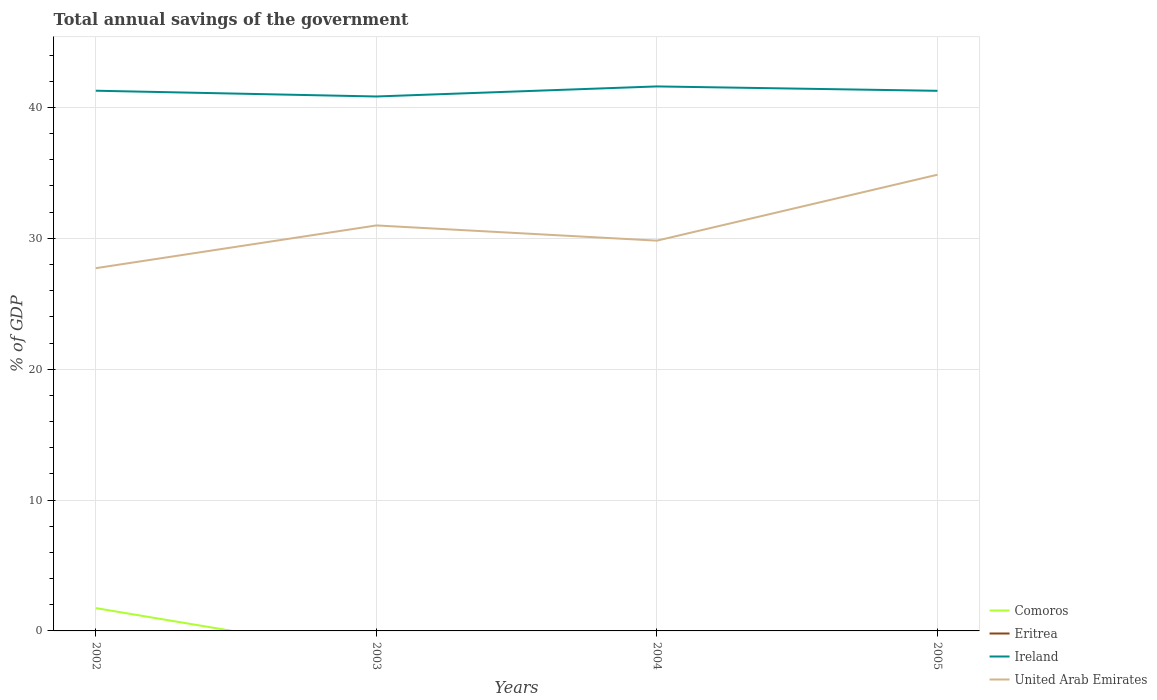What is the total total annual savings of the government in Ireland in the graph?
Make the answer very short. 0.34. What is the difference between the highest and the second highest total annual savings of the government in United Arab Emirates?
Make the answer very short. 7.14. How many years are there in the graph?
Your answer should be compact. 4. What is the difference between two consecutive major ticks on the Y-axis?
Give a very brief answer. 10. Are the values on the major ticks of Y-axis written in scientific E-notation?
Offer a terse response. No. Does the graph contain grids?
Ensure brevity in your answer.  Yes. What is the title of the graph?
Give a very brief answer. Total annual savings of the government. What is the label or title of the X-axis?
Your answer should be very brief. Years. What is the label or title of the Y-axis?
Provide a succinct answer. % of GDP. What is the % of GDP of Comoros in 2002?
Your response must be concise. 1.74. What is the % of GDP in Ireland in 2002?
Keep it short and to the point. 41.28. What is the % of GDP of United Arab Emirates in 2002?
Provide a succinct answer. 27.72. What is the % of GDP in Eritrea in 2003?
Keep it short and to the point. 0. What is the % of GDP of Ireland in 2003?
Make the answer very short. 40.84. What is the % of GDP of United Arab Emirates in 2003?
Ensure brevity in your answer.  30.98. What is the % of GDP in Ireland in 2004?
Ensure brevity in your answer.  41.61. What is the % of GDP of United Arab Emirates in 2004?
Offer a very short reply. 29.82. What is the % of GDP in Ireland in 2005?
Your response must be concise. 41.27. What is the % of GDP of United Arab Emirates in 2005?
Ensure brevity in your answer.  34.86. Across all years, what is the maximum % of GDP of Comoros?
Make the answer very short. 1.74. Across all years, what is the maximum % of GDP of Ireland?
Give a very brief answer. 41.61. Across all years, what is the maximum % of GDP of United Arab Emirates?
Provide a short and direct response. 34.86. Across all years, what is the minimum % of GDP of Comoros?
Your response must be concise. 0. Across all years, what is the minimum % of GDP of Ireland?
Provide a short and direct response. 40.84. Across all years, what is the minimum % of GDP in United Arab Emirates?
Your answer should be very brief. 27.72. What is the total % of GDP in Comoros in the graph?
Your answer should be compact. 1.74. What is the total % of GDP of Ireland in the graph?
Your answer should be compact. 164.99. What is the total % of GDP of United Arab Emirates in the graph?
Give a very brief answer. 123.38. What is the difference between the % of GDP in Ireland in 2002 and that in 2003?
Make the answer very short. 0.44. What is the difference between the % of GDP of United Arab Emirates in 2002 and that in 2003?
Provide a succinct answer. -3.27. What is the difference between the % of GDP in Ireland in 2002 and that in 2004?
Provide a succinct answer. -0.33. What is the difference between the % of GDP in United Arab Emirates in 2002 and that in 2004?
Offer a very short reply. -2.1. What is the difference between the % of GDP in Ireland in 2002 and that in 2005?
Offer a very short reply. 0.01. What is the difference between the % of GDP in United Arab Emirates in 2002 and that in 2005?
Provide a succinct answer. -7.14. What is the difference between the % of GDP in Ireland in 2003 and that in 2004?
Provide a succinct answer. -0.77. What is the difference between the % of GDP in United Arab Emirates in 2003 and that in 2004?
Your answer should be compact. 1.16. What is the difference between the % of GDP in Ireland in 2003 and that in 2005?
Keep it short and to the point. -0.43. What is the difference between the % of GDP of United Arab Emirates in 2003 and that in 2005?
Your response must be concise. -3.88. What is the difference between the % of GDP in Ireland in 2004 and that in 2005?
Make the answer very short. 0.34. What is the difference between the % of GDP of United Arab Emirates in 2004 and that in 2005?
Your answer should be very brief. -5.04. What is the difference between the % of GDP in Comoros in 2002 and the % of GDP in Ireland in 2003?
Your answer should be compact. -39.09. What is the difference between the % of GDP in Comoros in 2002 and the % of GDP in United Arab Emirates in 2003?
Make the answer very short. -29.24. What is the difference between the % of GDP of Ireland in 2002 and the % of GDP of United Arab Emirates in 2003?
Offer a terse response. 10.29. What is the difference between the % of GDP of Comoros in 2002 and the % of GDP of Ireland in 2004?
Ensure brevity in your answer.  -39.86. What is the difference between the % of GDP of Comoros in 2002 and the % of GDP of United Arab Emirates in 2004?
Keep it short and to the point. -28.08. What is the difference between the % of GDP in Ireland in 2002 and the % of GDP in United Arab Emirates in 2004?
Your answer should be compact. 11.46. What is the difference between the % of GDP of Comoros in 2002 and the % of GDP of Ireland in 2005?
Ensure brevity in your answer.  -39.53. What is the difference between the % of GDP in Comoros in 2002 and the % of GDP in United Arab Emirates in 2005?
Provide a succinct answer. -33.12. What is the difference between the % of GDP of Ireland in 2002 and the % of GDP of United Arab Emirates in 2005?
Provide a short and direct response. 6.42. What is the difference between the % of GDP in Ireland in 2003 and the % of GDP in United Arab Emirates in 2004?
Provide a succinct answer. 11.02. What is the difference between the % of GDP of Ireland in 2003 and the % of GDP of United Arab Emirates in 2005?
Your answer should be compact. 5.98. What is the difference between the % of GDP in Ireland in 2004 and the % of GDP in United Arab Emirates in 2005?
Provide a short and direct response. 6.75. What is the average % of GDP of Comoros per year?
Give a very brief answer. 0.44. What is the average % of GDP in Ireland per year?
Provide a succinct answer. 41.25. What is the average % of GDP in United Arab Emirates per year?
Your answer should be compact. 30.85. In the year 2002, what is the difference between the % of GDP of Comoros and % of GDP of Ireland?
Give a very brief answer. -39.53. In the year 2002, what is the difference between the % of GDP of Comoros and % of GDP of United Arab Emirates?
Your answer should be compact. -25.97. In the year 2002, what is the difference between the % of GDP in Ireland and % of GDP in United Arab Emirates?
Make the answer very short. 13.56. In the year 2003, what is the difference between the % of GDP of Ireland and % of GDP of United Arab Emirates?
Offer a terse response. 9.85. In the year 2004, what is the difference between the % of GDP of Ireland and % of GDP of United Arab Emirates?
Your answer should be compact. 11.78. In the year 2005, what is the difference between the % of GDP in Ireland and % of GDP in United Arab Emirates?
Ensure brevity in your answer.  6.41. What is the ratio of the % of GDP in Ireland in 2002 to that in 2003?
Provide a succinct answer. 1.01. What is the ratio of the % of GDP of United Arab Emirates in 2002 to that in 2003?
Ensure brevity in your answer.  0.89. What is the ratio of the % of GDP of Ireland in 2002 to that in 2004?
Your response must be concise. 0.99. What is the ratio of the % of GDP in United Arab Emirates in 2002 to that in 2004?
Make the answer very short. 0.93. What is the ratio of the % of GDP of Ireland in 2002 to that in 2005?
Give a very brief answer. 1. What is the ratio of the % of GDP of United Arab Emirates in 2002 to that in 2005?
Give a very brief answer. 0.8. What is the ratio of the % of GDP in Ireland in 2003 to that in 2004?
Your response must be concise. 0.98. What is the ratio of the % of GDP of United Arab Emirates in 2003 to that in 2004?
Your answer should be compact. 1.04. What is the ratio of the % of GDP of Ireland in 2003 to that in 2005?
Give a very brief answer. 0.99. What is the ratio of the % of GDP of United Arab Emirates in 2003 to that in 2005?
Your answer should be compact. 0.89. What is the ratio of the % of GDP of Ireland in 2004 to that in 2005?
Ensure brevity in your answer.  1.01. What is the ratio of the % of GDP in United Arab Emirates in 2004 to that in 2005?
Your response must be concise. 0.86. What is the difference between the highest and the second highest % of GDP of Ireland?
Provide a succinct answer. 0.33. What is the difference between the highest and the second highest % of GDP in United Arab Emirates?
Your answer should be compact. 3.88. What is the difference between the highest and the lowest % of GDP in Comoros?
Your response must be concise. 1.74. What is the difference between the highest and the lowest % of GDP in Ireland?
Keep it short and to the point. 0.77. What is the difference between the highest and the lowest % of GDP of United Arab Emirates?
Your answer should be very brief. 7.14. 